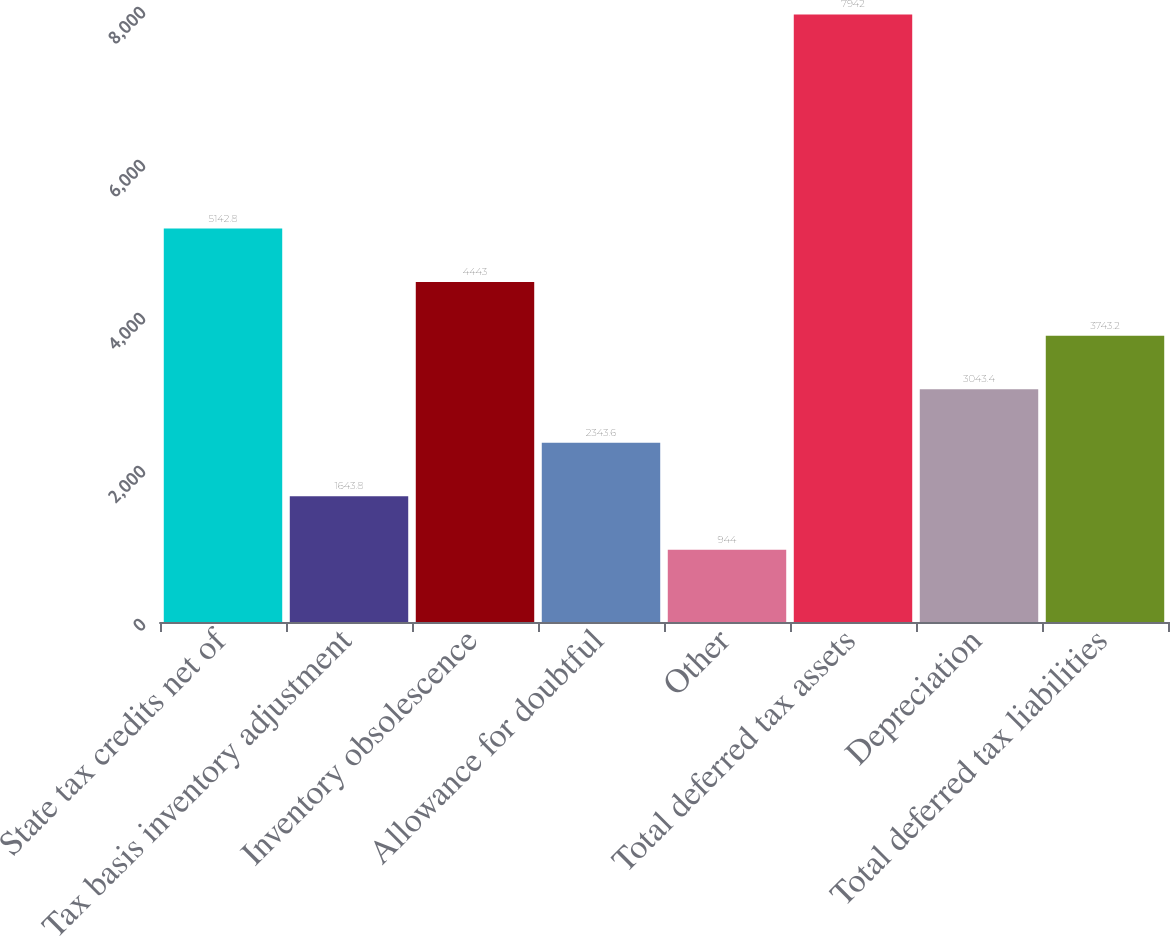<chart> <loc_0><loc_0><loc_500><loc_500><bar_chart><fcel>State tax credits net of<fcel>Tax basis inventory adjustment<fcel>Inventory obsolescence<fcel>Allowance for doubtful<fcel>Other<fcel>Total deferred tax assets<fcel>Depreciation<fcel>Total deferred tax liabilities<nl><fcel>5142.8<fcel>1643.8<fcel>4443<fcel>2343.6<fcel>944<fcel>7942<fcel>3043.4<fcel>3743.2<nl></chart> 